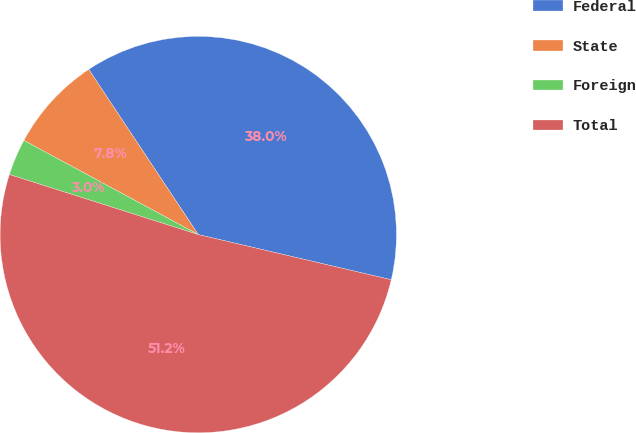<chart> <loc_0><loc_0><loc_500><loc_500><pie_chart><fcel>Federal<fcel>State<fcel>Foreign<fcel>Total<nl><fcel>37.98%<fcel>7.8%<fcel>2.98%<fcel>51.24%<nl></chart> 